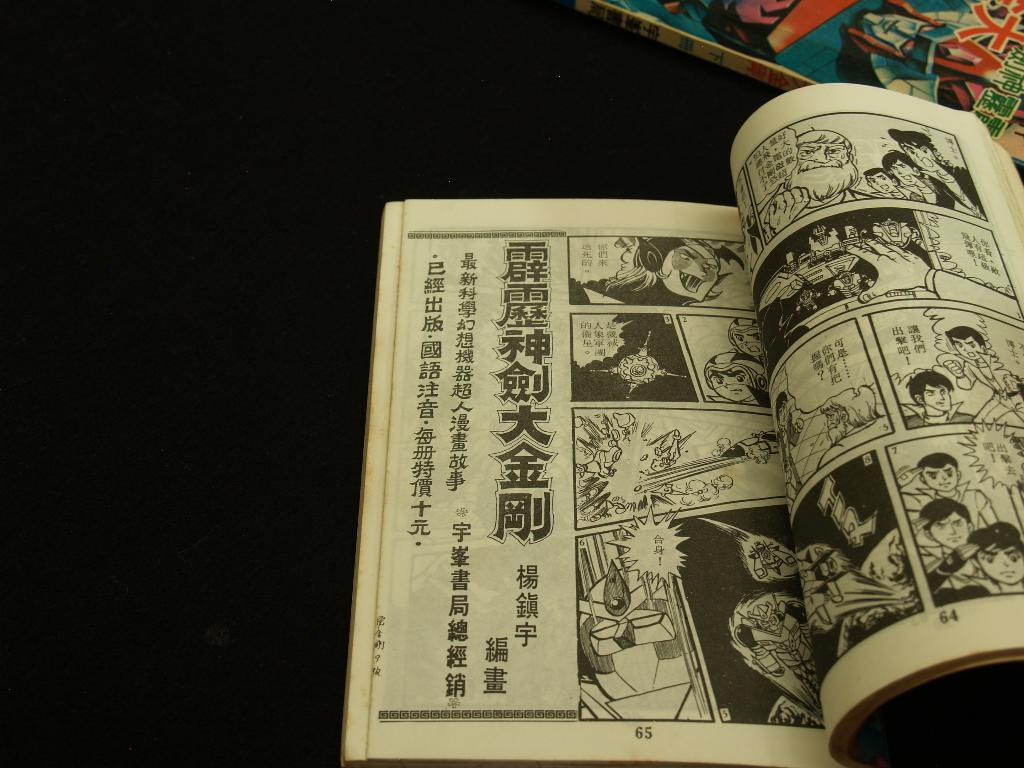Provide a one-sentence caption for the provided image. A black and white comic bank is opened to pages 64 and 65. 